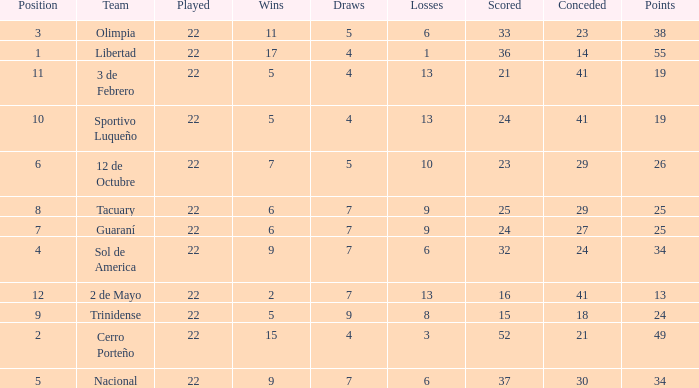What is the fewest wins that has fewer than 23 goals scored, team of 2 de Mayo, and fewer than 7 draws? None. 